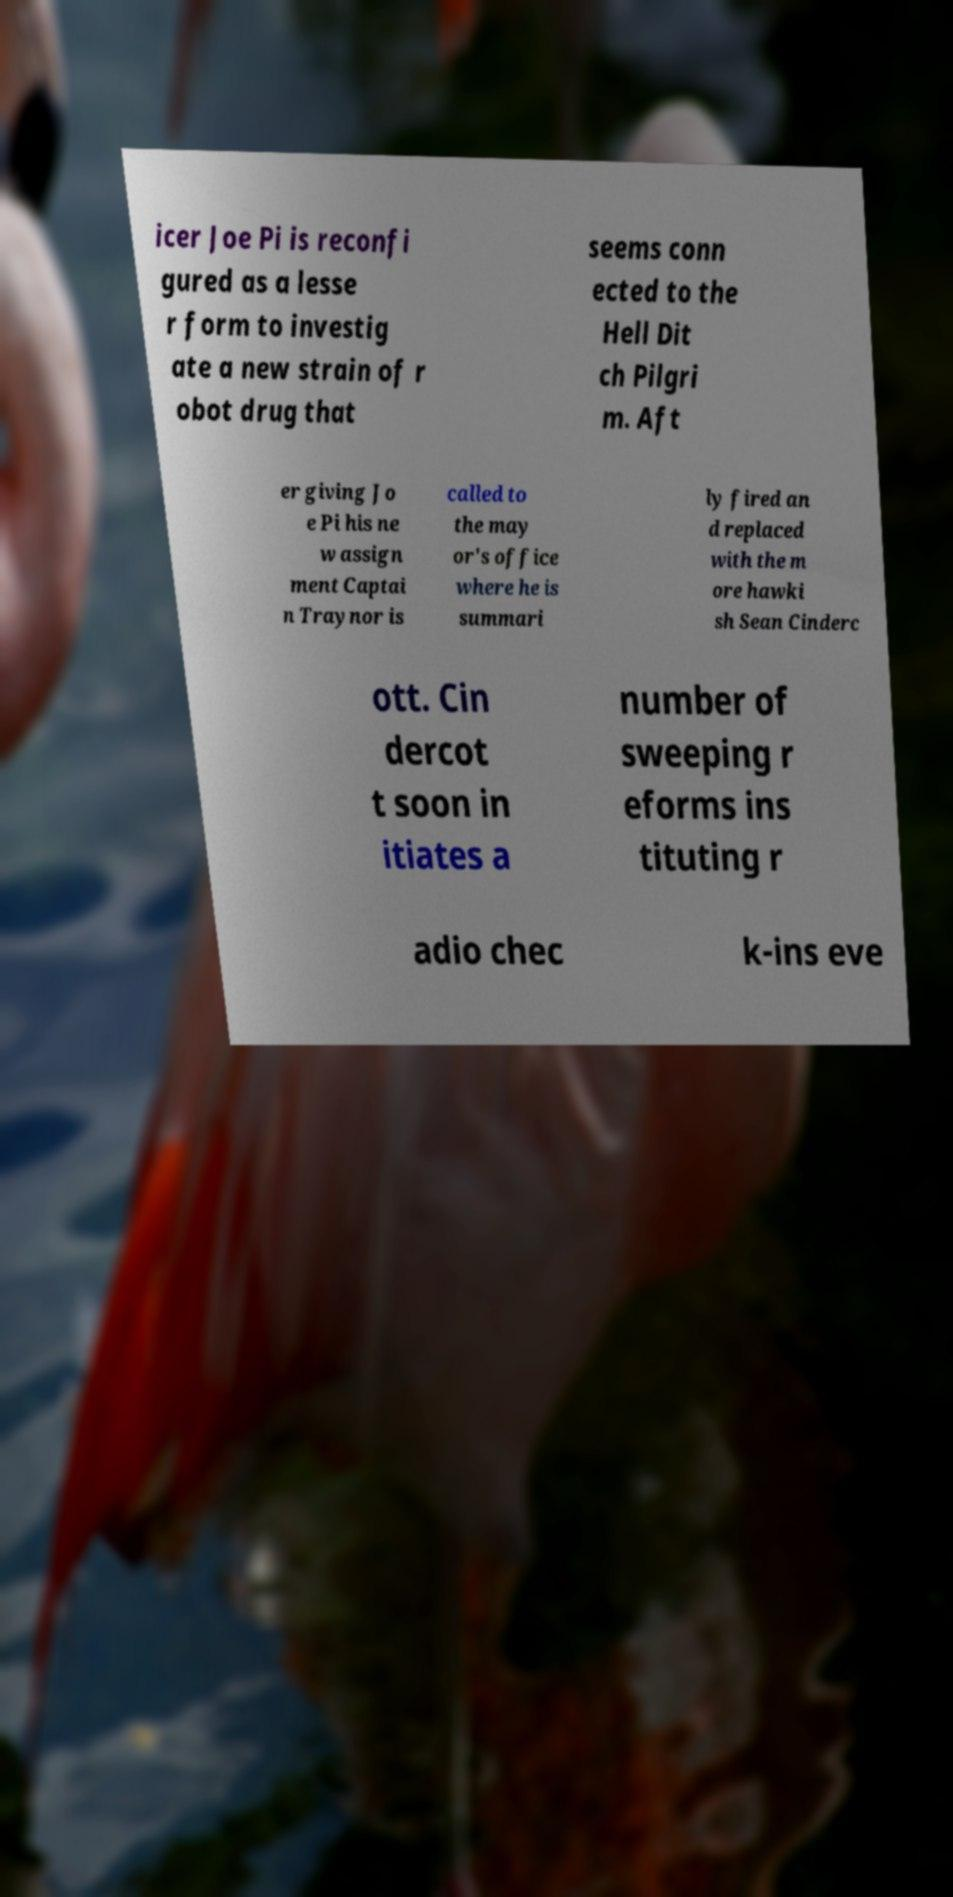Could you extract and type out the text from this image? icer Joe Pi is reconfi gured as a lesse r form to investig ate a new strain of r obot drug that seems conn ected to the Hell Dit ch Pilgri m. Aft er giving Jo e Pi his ne w assign ment Captai n Traynor is called to the may or's office where he is summari ly fired an d replaced with the m ore hawki sh Sean Cinderc ott. Cin dercot t soon in itiates a number of sweeping r eforms ins tituting r adio chec k-ins eve 